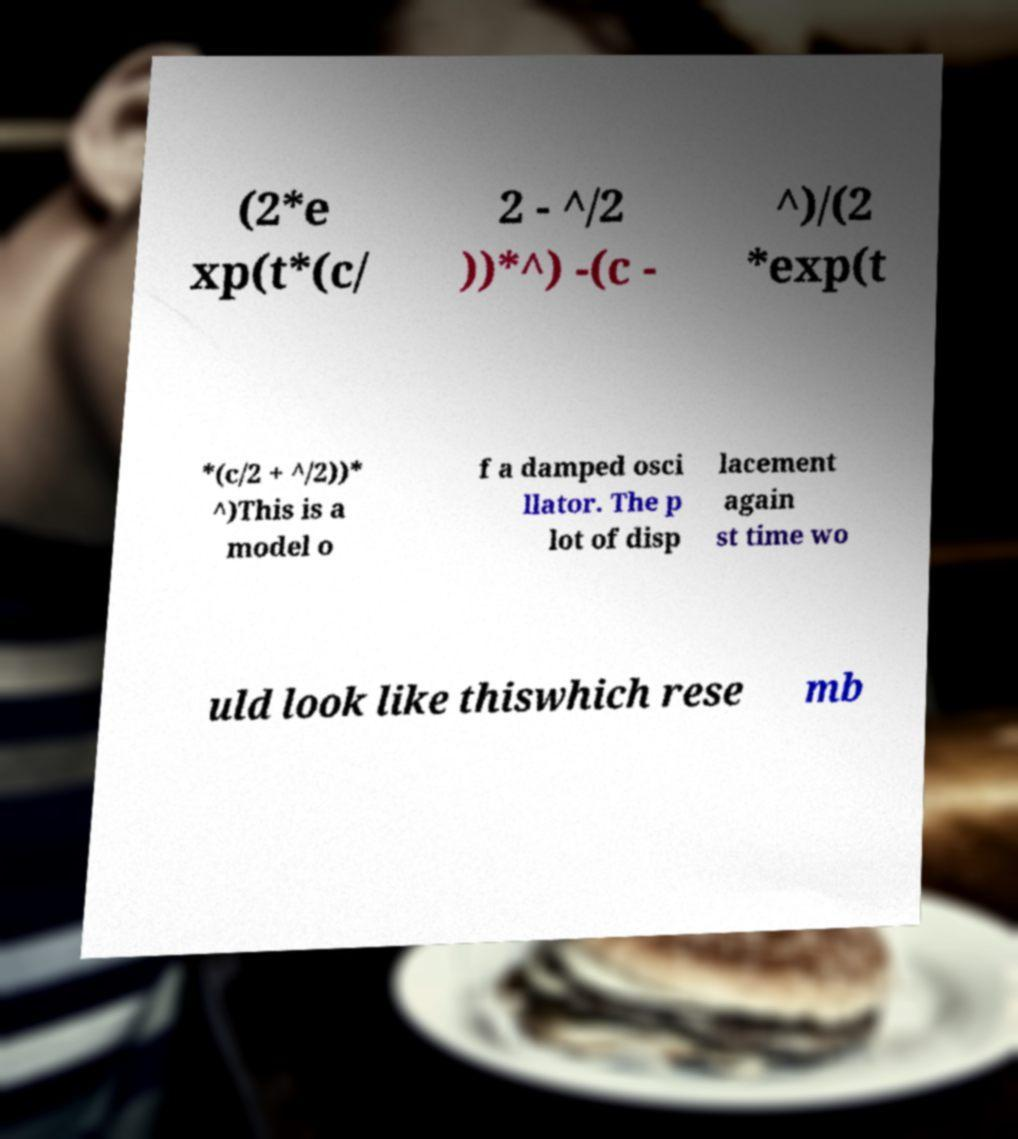Please read and relay the text visible in this image. What does it say? (2*e xp(t*(c/ 2 - ^/2 ))*^) -(c - ^)/(2 *exp(t *(c/2 + ^/2))* ^)This is a model o f a damped osci llator. The p lot of disp lacement again st time wo uld look like thiswhich rese mb 